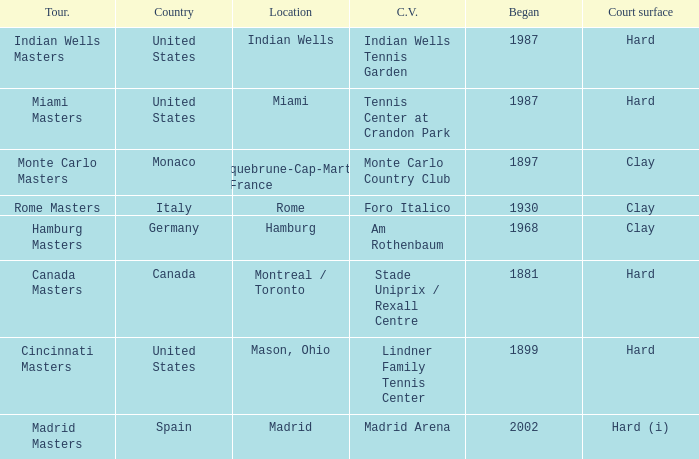Which country has rome as a city? Italy. 